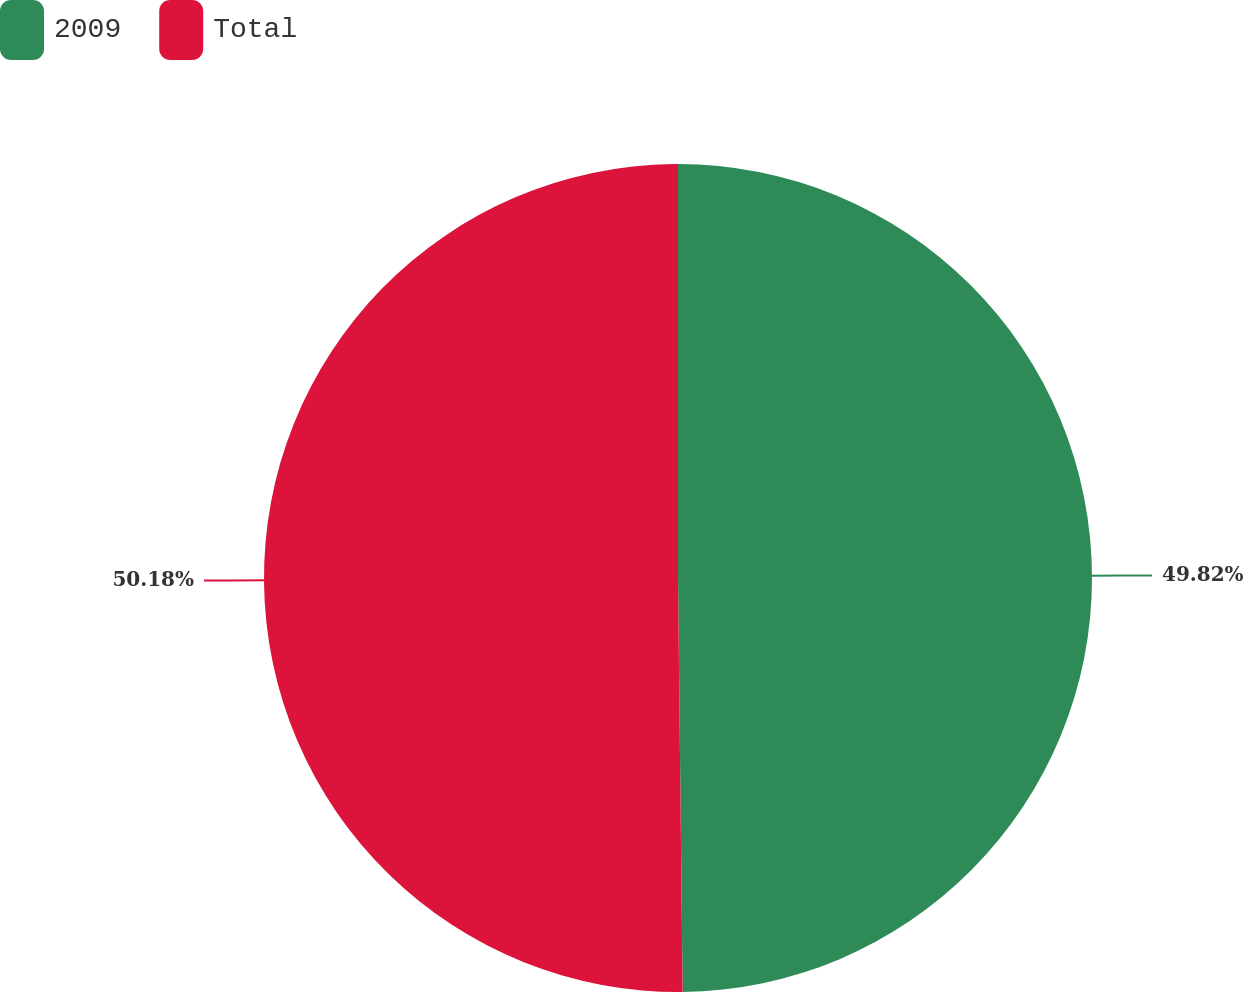<chart> <loc_0><loc_0><loc_500><loc_500><pie_chart><fcel>2009<fcel>Total<nl><fcel>49.82%<fcel>50.18%<nl></chart> 